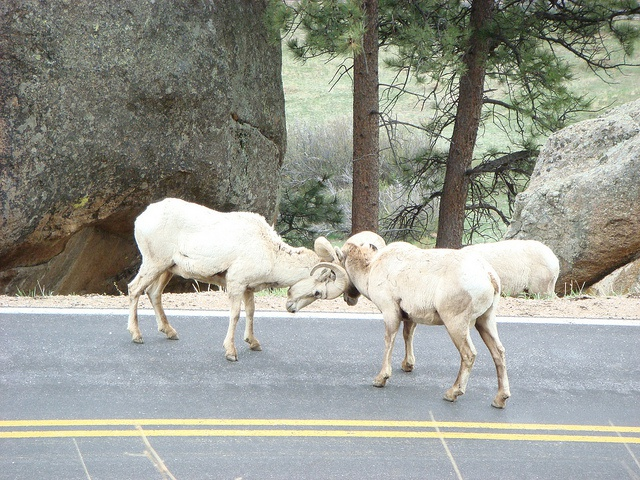Describe the objects in this image and their specific colors. I can see sheep in gray, ivory, darkgray, and lightgray tones, sheep in gray, ivory, darkgray, lightgray, and tan tones, and sheep in gray, ivory, darkgray, lightgray, and tan tones in this image. 